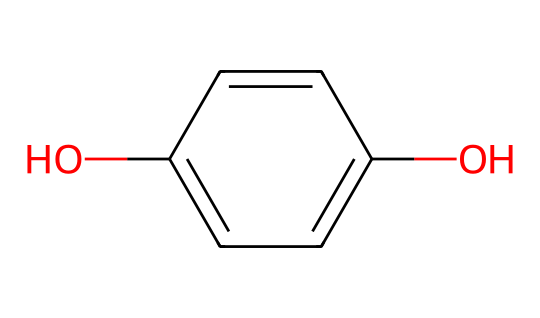What is the molecular formula of this compound? To determine the molecular formula, we need to count the atoms in the provided SMILES representation: C1=CC=C(O)C=C1. Here, there are 8 carbon atoms (C), 6 hydrogen atoms (H), and 2 oxygen atoms (O). Therefore, the molecular formula is C8H8O2.
Answer: C8H8O2 How many hydrogen atoms are present? By analyzing the SMILES, specifically by identifying the hydrogens connected to the carbon atoms in the structure, we find that there are 8 hydrogen atoms associated with that structure.
Answer: 8 What type of compound is represented by this chemical structure? The presence of the hydroxyl group (-OH) and the six-membered carbon ring indicates that this compound is a phenol. Phenolic compounds typically have aromaticity due to the alternating double bonds.
Answer: phenol Is this chemical soluble in water? The presence of the hydroxyl (-OH) group enhances the solubility in water due to the ability to form hydrogen bonds. Therefore, it is likely that the compound is soluble in water.
Answer: yes What type of reaction might this compound participate in as a developing agent? Phenolic compounds like this one commonly participate in reduction reactions, especially in photographic development, where they reduce silver ions to metallic silver. Therefore, it is involved in reduction reactions.
Answer: reduction How many rings are present in the structure? The provided SMILES shows a cyclic structure (C1=CC=C(O)C=C1), indicating that there is one aromatic ring in the compound. Thus, there is one ring present.
Answer: 1 